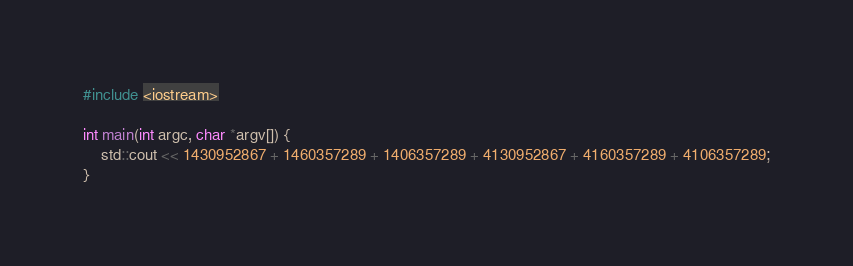Convert code to text. <code><loc_0><loc_0><loc_500><loc_500><_C++_>#include <iostream>

int main(int argc, char *argv[]) {  
	std::cout << 1430952867 + 1460357289 + 1406357289 + 4130952867 + 4160357289 + 4106357289;
}</code> 